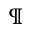<formula> <loc_0><loc_0><loc_500><loc_500>\ m a t h p a r a g r a p h</formula> 